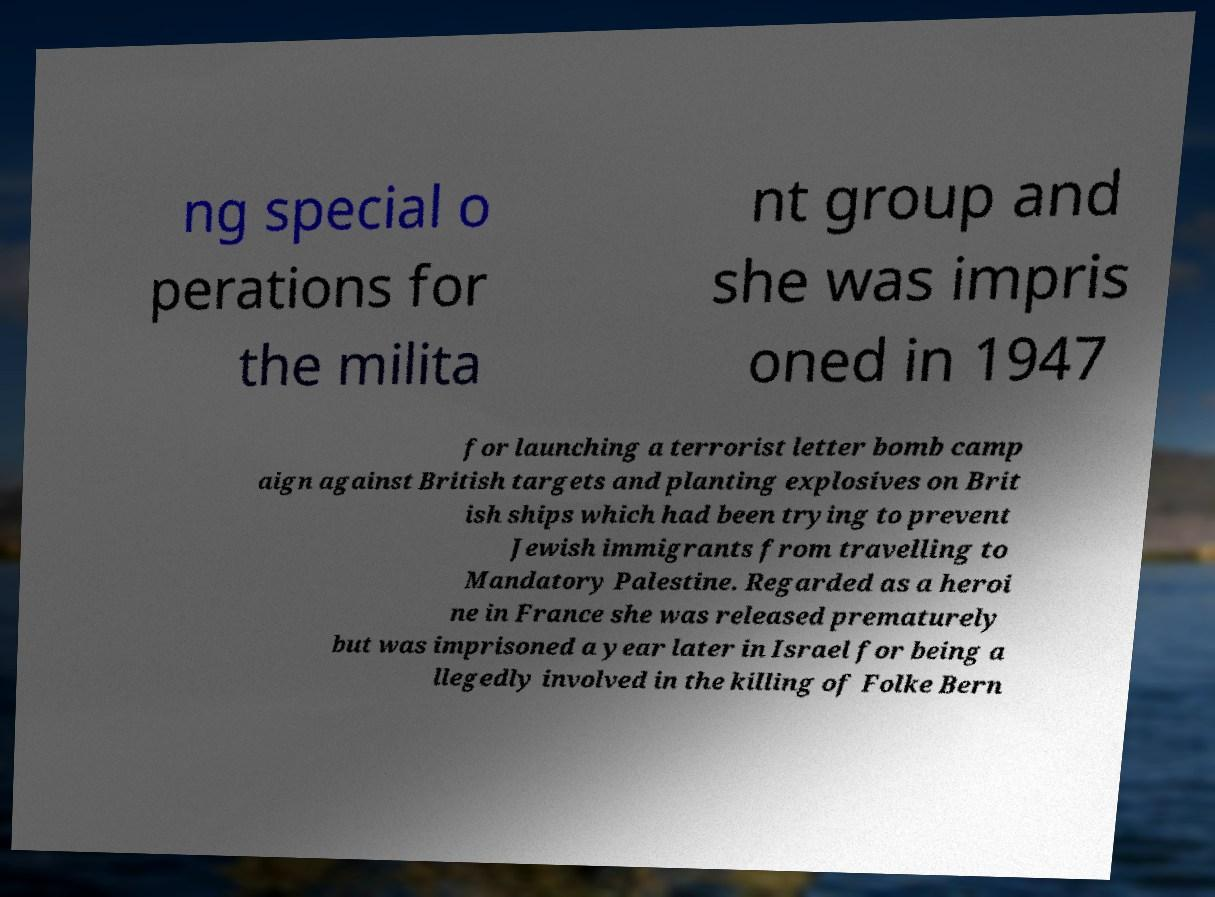Please identify and transcribe the text found in this image. ng special o perations for the milita nt group and she was impris oned in 1947 for launching a terrorist letter bomb camp aign against British targets and planting explosives on Brit ish ships which had been trying to prevent Jewish immigrants from travelling to Mandatory Palestine. Regarded as a heroi ne in France she was released prematurely but was imprisoned a year later in Israel for being a llegedly involved in the killing of Folke Bern 